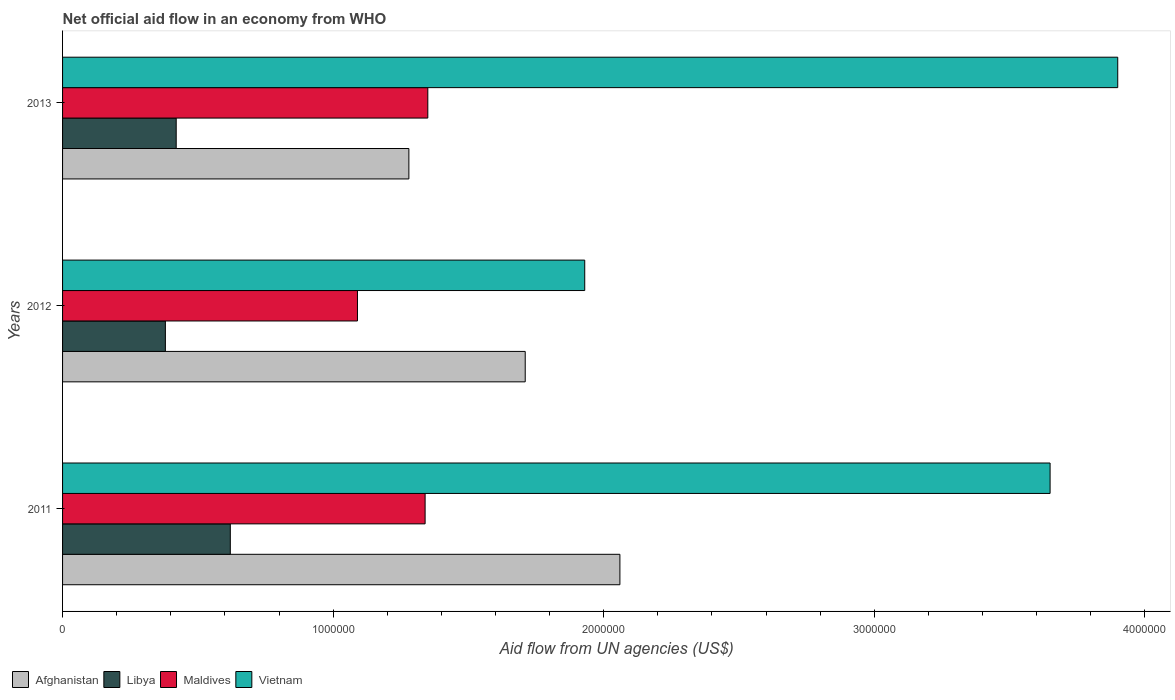How many groups of bars are there?
Give a very brief answer. 3. Are the number of bars per tick equal to the number of legend labels?
Offer a terse response. Yes. Are the number of bars on each tick of the Y-axis equal?
Provide a short and direct response. Yes. How many bars are there on the 1st tick from the top?
Make the answer very short. 4. In how many cases, is the number of bars for a given year not equal to the number of legend labels?
Your answer should be very brief. 0. What is the net official aid flow in Afghanistan in 2012?
Offer a very short reply. 1.71e+06. Across all years, what is the maximum net official aid flow in Libya?
Provide a short and direct response. 6.20e+05. Across all years, what is the minimum net official aid flow in Afghanistan?
Keep it short and to the point. 1.28e+06. In which year was the net official aid flow in Maldives maximum?
Ensure brevity in your answer.  2013. In which year was the net official aid flow in Maldives minimum?
Your answer should be very brief. 2012. What is the total net official aid flow in Libya in the graph?
Your answer should be very brief. 1.42e+06. What is the difference between the net official aid flow in Maldives in 2011 and that in 2012?
Give a very brief answer. 2.50e+05. What is the difference between the net official aid flow in Libya in 2013 and the net official aid flow in Afghanistan in 2012?
Your answer should be very brief. -1.29e+06. What is the average net official aid flow in Afghanistan per year?
Your answer should be compact. 1.68e+06. In the year 2011, what is the difference between the net official aid flow in Vietnam and net official aid flow in Afghanistan?
Your answer should be compact. 1.59e+06. In how many years, is the net official aid flow in Maldives greater than 1200000 US$?
Provide a short and direct response. 2. What is the ratio of the net official aid flow in Maldives in 2011 to that in 2013?
Keep it short and to the point. 0.99. Is the difference between the net official aid flow in Vietnam in 2011 and 2012 greater than the difference between the net official aid flow in Afghanistan in 2011 and 2012?
Make the answer very short. Yes. Is it the case that in every year, the sum of the net official aid flow in Maldives and net official aid flow in Vietnam is greater than the sum of net official aid flow in Libya and net official aid flow in Afghanistan?
Make the answer very short. No. What does the 1st bar from the top in 2013 represents?
Your answer should be very brief. Vietnam. What does the 2nd bar from the bottom in 2013 represents?
Ensure brevity in your answer.  Libya. Is it the case that in every year, the sum of the net official aid flow in Vietnam and net official aid flow in Afghanistan is greater than the net official aid flow in Maldives?
Provide a succinct answer. Yes. How many bars are there?
Offer a terse response. 12. How many years are there in the graph?
Provide a short and direct response. 3. What is the difference between two consecutive major ticks on the X-axis?
Your response must be concise. 1.00e+06. What is the title of the graph?
Make the answer very short. Net official aid flow in an economy from WHO. Does "Lower middle income" appear as one of the legend labels in the graph?
Keep it short and to the point. No. What is the label or title of the X-axis?
Give a very brief answer. Aid flow from UN agencies (US$). What is the label or title of the Y-axis?
Make the answer very short. Years. What is the Aid flow from UN agencies (US$) in Afghanistan in 2011?
Give a very brief answer. 2.06e+06. What is the Aid flow from UN agencies (US$) in Libya in 2011?
Your answer should be very brief. 6.20e+05. What is the Aid flow from UN agencies (US$) of Maldives in 2011?
Offer a very short reply. 1.34e+06. What is the Aid flow from UN agencies (US$) of Vietnam in 2011?
Give a very brief answer. 3.65e+06. What is the Aid flow from UN agencies (US$) in Afghanistan in 2012?
Your answer should be compact. 1.71e+06. What is the Aid flow from UN agencies (US$) of Maldives in 2012?
Make the answer very short. 1.09e+06. What is the Aid flow from UN agencies (US$) of Vietnam in 2012?
Offer a terse response. 1.93e+06. What is the Aid flow from UN agencies (US$) of Afghanistan in 2013?
Offer a very short reply. 1.28e+06. What is the Aid flow from UN agencies (US$) of Libya in 2013?
Ensure brevity in your answer.  4.20e+05. What is the Aid flow from UN agencies (US$) of Maldives in 2013?
Make the answer very short. 1.35e+06. What is the Aid flow from UN agencies (US$) in Vietnam in 2013?
Ensure brevity in your answer.  3.90e+06. Across all years, what is the maximum Aid flow from UN agencies (US$) in Afghanistan?
Your answer should be compact. 2.06e+06. Across all years, what is the maximum Aid flow from UN agencies (US$) in Libya?
Make the answer very short. 6.20e+05. Across all years, what is the maximum Aid flow from UN agencies (US$) in Maldives?
Make the answer very short. 1.35e+06. Across all years, what is the maximum Aid flow from UN agencies (US$) in Vietnam?
Provide a short and direct response. 3.90e+06. Across all years, what is the minimum Aid flow from UN agencies (US$) in Afghanistan?
Offer a terse response. 1.28e+06. Across all years, what is the minimum Aid flow from UN agencies (US$) of Maldives?
Give a very brief answer. 1.09e+06. Across all years, what is the minimum Aid flow from UN agencies (US$) of Vietnam?
Your answer should be very brief. 1.93e+06. What is the total Aid flow from UN agencies (US$) in Afghanistan in the graph?
Keep it short and to the point. 5.05e+06. What is the total Aid flow from UN agencies (US$) in Libya in the graph?
Your response must be concise. 1.42e+06. What is the total Aid flow from UN agencies (US$) of Maldives in the graph?
Your response must be concise. 3.78e+06. What is the total Aid flow from UN agencies (US$) of Vietnam in the graph?
Offer a very short reply. 9.48e+06. What is the difference between the Aid flow from UN agencies (US$) of Afghanistan in 2011 and that in 2012?
Provide a short and direct response. 3.50e+05. What is the difference between the Aid flow from UN agencies (US$) of Libya in 2011 and that in 2012?
Give a very brief answer. 2.40e+05. What is the difference between the Aid flow from UN agencies (US$) of Maldives in 2011 and that in 2012?
Keep it short and to the point. 2.50e+05. What is the difference between the Aid flow from UN agencies (US$) in Vietnam in 2011 and that in 2012?
Offer a very short reply. 1.72e+06. What is the difference between the Aid flow from UN agencies (US$) of Afghanistan in 2011 and that in 2013?
Your response must be concise. 7.80e+05. What is the difference between the Aid flow from UN agencies (US$) of Libya in 2011 and that in 2013?
Keep it short and to the point. 2.00e+05. What is the difference between the Aid flow from UN agencies (US$) in Vietnam in 2011 and that in 2013?
Your response must be concise. -2.50e+05. What is the difference between the Aid flow from UN agencies (US$) in Afghanistan in 2012 and that in 2013?
Your answer should be compact. 4.30e+05. What is the difference between the Aid flow from UN agencies (US$) of Libya in 2012 and that in 2013?
Your answer should be compact. -4.00e+04. What is the difference between the Aid flow from UN agencies (US$) in Maldives in 2012 and that in 2013?
Provide a succinct answer. -2.60e+05. What is the difference between the Aid flow from UN agencies (US$) in Vietnam in 2012 and that in 2013?
Provide a short and direct response. -1.97e+06. What is the difference between the Aid flow from UN agencies (US$) in Afghanistan in 2011 and the Aid flow from UN agencies (US$) in Libya in 2012?
Keep it short and to the point. 1.68e+06. What is the difference between the Aid flow from UN agencies (US$) in Afghanistan in 2011 and the Aid flow from UN agencies (US$) in Maldives in 2012?
Give a very brief answer. 9.70e+05. What is the difference between the Aid flow from UN agencies (US$) in Libya in 2011 and the Aid flow from UN agencies (US$) in Maldives in 2012?
Ensure brevity in your answer.  -4.70e+05. What is the difference between the Aid flow from UN agencies (US$) of Libya in 2011 and the Aid flow from UN agencies (US$) of Vietnam in 2012?
Give a very brief answer. -1.31e+06. What is the difference between the Aid flow from UN agencies (US$) of Maldives in 2011 and the Aid flow from UN agencies (US$) of Vietnam in 2012?
Make the answer very short. -5.90e+05. What is the difference between the Aid flow from UN agencies (US$) in Afghanistan in 2011 and the Aid flow from UN agencies (US$) in Libya in 2013?
Provide a short and direct response. 1.64e+06. What is the difference between the Aid flow from UN agencies (US$) in Afghanistan in 2011 and the Aid flow from UN agencies (US$) in Maldives in 2013?
Make the answer very short. 7.10e+05. What is the difference between the Aid flow from UN agencies (US$) of Afghanistan in 2011 and the Aid flow from UN agencies (US$) of Vietnam in 2013?
Your answer should be very brief. -1.84e+06. What is the difference between the Aid flow from UN agencies (US$) in Libya in 2011 and the Aid flow from UN agencies (US$) in Maldives in 2013?
Provide a succinct answer. -7.30e+05. What is the difference between the Aid flow from UN agencies (US$) of Libya in 2011 and the Aid flow from UN agencies (US$) of Vietnam in 2013?
Keep it short and to the point. -3.28e+06. What is the difference between the Aid flow from UN agencies (US$) in Maldives in 2011 and the Aid flow from UN agencies (US$) in Vietnam in 2013?
Provide a short and direct response. -2.56e+06. What is the difference between the Aid flow from UN agencies (US$) in Afghanistan in 2012 and the Aid flow from UN agencies (US$) in Libya in 2013?
Offer a terse response. 1.29e+06. What is the difference between the Aid flow from UN agencies (US$) of Afghanistan in 2012 and the Aid flow from UN agencies (US$) of Vietnam in 2013?
Provide a succinct answer. -2.19e+06. What is the difference between the Aid flow from UN agencies (US$) of Libya in 2012 and the Aid flow from UN agencies (US$) of Maldives in 2013?
Offer a very short reply. -9.70e+05. What is the difference between the Aid flow from UN agencies (US$) of Libya in 2012 and the Aid flow from UN agencies (US$) of Vietnam in 2013?
Keep it short and to the point. -3.52e+06. What is the difference between the Aid flow from UN agencies (US$) in Maldives in 2012 and the Aid flow from UN agencies (US$) in Vietnam in 2013?
Ensure brevity in your answer.  -2.81e+06. What is the average Aid flow from UN agencies (US$) in Afghanistan per year?
Ensure brevity in your answer.  1.68e+06. What is the average Aid flow from UN agencies (US$) in Libya per year?
Make the answer very short. 4.73e+05. What is the average Aid flow from UN agencies (US$) in Maldives per year?
Provide a succinct answer. 1.26e+06. What is the average Aid flow from UN agencies (US$) of Vietnam per year?
Your answer should be very brief. 3.16e+06. In the year 2011, what is the difference between the Aid flow from UN agencies (US$) of Afghanistan and Aid flow from UN agencies (US$) of Libya?
Offer a terse response. 1.44e+06. In the year 2011, what is the difference between the Aid flow from UN agencies (US$) of Afghanistan and Aid flow from UN agencies (US$) of Maldives?
Your response must be concise. 7.20e+05. In the year 2011, what is the difference between the Aid flow from UN agencies (US$) of Afghanistan and Aid flow from UN agencies (US$) of Vietnam?
Your answer should be very brief. -1.59e+06. In the year 2011, what is the difference between the Aid flow from UN agencies (US$) in Libya and Aid flow from UN agencies (US$) in Maldives?
Offer a terse response. -7.20e+05. In the year 2011, what is the difference between the Aid flow from UN agencies (US$) of Libya and Aid flow from UN agencies (US$) of Vietnam?
Your answer should be compact. -3.03e+06. In the year 2011, what is the difference between the Aid flow from UN agencies (US$) in Maldives and Aid flow from UN agencies (US$) in Vietnam?
Make the answer very short. -2.31e+06. In the year 2012, what is the difference between the Aid flow from UN agencies (US$) of Afghanistan and Aid flow from UN agencies (US$) of Libya?
Offer a very short reply. 1.33e+06. In the year 2012, what is the difference between the Aid flow from UN agencies (US$) in Afghanistan and Aid flow from UN agencies (US$) in Maldives?
Offer a terse response. 6.20e+05. In the year 2012, what is the difference between the Aid flow from UN agencies (US$) of Libya and Aid flow from UN agencies (US$) of Maldives?
Offer a very short reply. -7.10e+05. In the year 2012, what is the difference between the Aid flow from UN agencies (US$) of Libya and Aid flow from UN agencies (US$) of Vietnam?
Make the answer very short. -1.55e+06. In the year 2012, what is the difference between the Aid flow from UN agencies (US$) in Maldives and Aid flow from UN agencies (US$) in Vietnam?
Ensure brevity in your answer.  -8.40e+05. In the year 2013, what is the difference between the Aid flow from UN agencies (US$) of Afghanistan and Aid flow from UN agencies (US$) of Libya?
Your answer should be compact. 8.60e+05. In the year 2013, what is the difference between the Aid flow from UN agencies (US$) in Afghanistan and Aid flow from UN agencies (US$) in Maldives?
Your answer should be very brief. -7.00e+04. In the year 2013, what is the difference between the Aid flow from UN agencies (US$) of Afghanistan and Aid flow from UN agencies (US$) of Vietnam?
Offer a terse response. -2.62e+06. In the year 2013, what is the difference between the Aid flow from UN agencies (US$) of Libya and Aid flow from UN agencies (US$) of Maldives?
Your answer should be very brief. -9.30e+05. In the year 2013, what is the difference between the Aid flow from UN agencies (US$) in Libya and Aid flow from UN agencies (US$) in Vietnam?
Give a very brief answer. -3.48e+06. In the year 2013, what is the difference between the Aid flow from UN agencies (US$) of Maldives and Aid flow from UN agencies (US$) of Vietnam?
Make the answer very short. -2.55e+06. What is the ratio of the Aid flow from UN agencies (US$) of Afghanistan in 2011 to that in 2012?
Keep it short and to the point. 1.2. What is the ratio of the Aid flow from UN agencies (US$) of Libya in 2011 to that in 2012?
Provide a succinct answer. 1.63. What is the ratio of the Aid flow from UN agencies (US$) in Maldives in 2011 to that in 2012?
Keep it short and to the point. 1.23. What is the ratio of the Aid flow from UN agencies (US$) in Vietnam in 2011 to that in 2012?
Your answer should be compact. 1.89. What is the ratio of the Aid flow from UN agencies (US$) in Afghanistan in 2011 to that in 2013?
Your answer should be compact. 1.61. What is the ratio of the Aid flow from UN agencies (US$) in Libya in 2011 to that in 2013?
Give a very brief answer. 1.48. What is the ratio of the Aid flow from UN agencies (US$) in Vietnam in 2011 to that in 2013?
Make the answer very short. 0.94. What is the ratio of the Aid flow from UN agencies (US$) of Afghanistan in 2012 to that in 2013?
Keep it short and to the point. 1.34. What is the ratio of the Aid flow from UN agencies (US$) in Libya in 2012 to that in 2013?
Your response must be concise. 0.9. What is the ratio of the Aid flow from UN agencies (US$) of Maldives in 2012 to that in 2013?
Provide a short and direct response. 0.81. What is the ratio of the Aid flow from UN agencies (US$) in Vietnam in 2012 to that in 2013?
Offer a very short reply. 0.49. What is the difference between the highest and the lowest Aid flow from UN agencies (US$) of Afghanistan?
Your answer should be very brief. 7.80e+05. What is the difference between the highest and the lowest Aid flow from UN agencies (US$) of Vietnam?
Keep it short and to the point. 1.97e+06. 